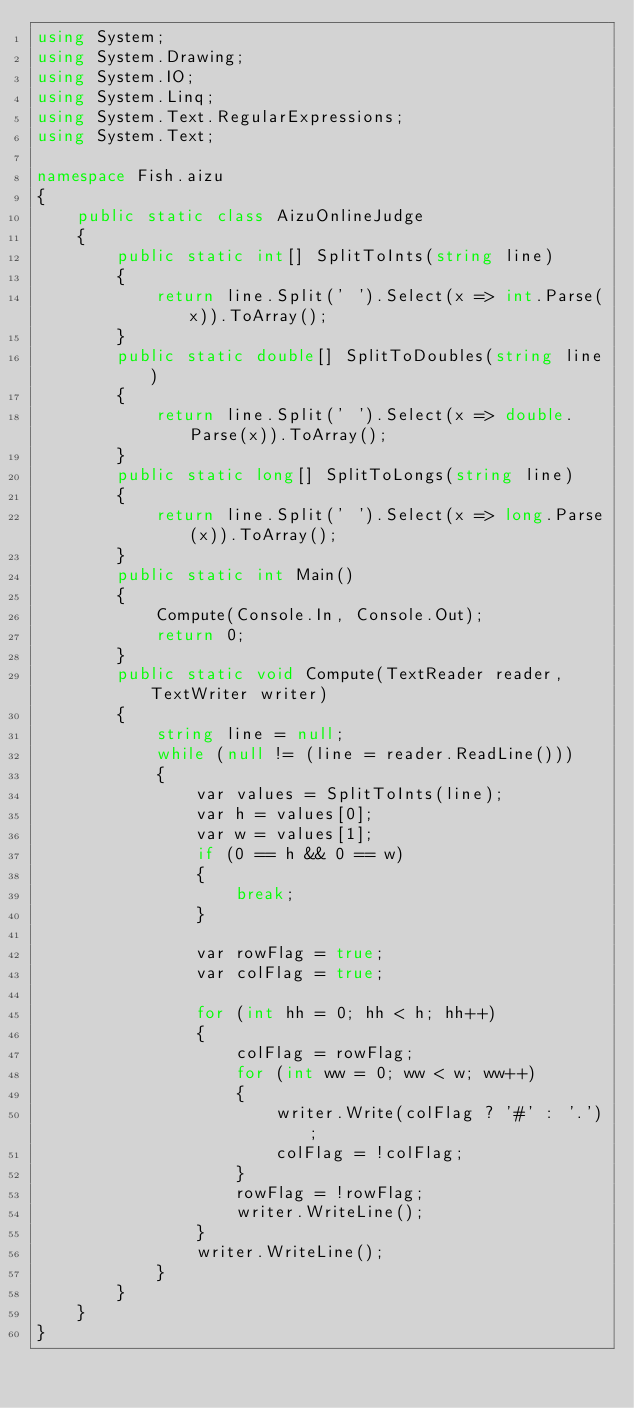Convert code to text. <code><loc_0><loc_0><loc_500><loc_500><_C#_>using System;
using System.Drawing;
using System.IO;
using System.Linq;
using System.Text.RegularExpressions;
using System.Text;

namespace Fish.aizu
{
	public static class AizuOnlineJudge
	{
		public static int[] SplitToInts(string line)
		{
			return line.Split(' ').Select(x => int.Parse(x)).ToArray();
		}
		public static double[] SplitToDoubles(string line)
		{
			return line.Split(' ').Select(x => double.Parse(x)).ToArray();
		}
		public static long[] SplitToLongs(string line)
		{
			return line.Split(' ').Select(x => long.Parse(x)).ToArray();
		}
		public static int Main()
		{
			Compute(Console.In, Console.Out);
			return 0;
		}
		public static void Compute(TextReader reader, TextWriter writer)
		{
			string line = null;
			while (null != (line = reader.ReadLine()))
			{
				var values = SplitToInts(line);
				var h = values[0];
				var w = values[1];
				if (0 == h && 0 == w)
				{
					break;
				}
				
				var rowFlag = true;
				var colFlag = true;
				
				for (int hh = 0; hh < h; hh++)
				{
					colFlag = rowFlag;
					for (int ww = 0; ww < w; ww++)
					{
						writer.Write(colFlag ? '#' : '.');
						colFlag = !colFlag;
					}
					rowFlag = !rowFlag;
					writer.WriteLine();
				}
				writer.WriteLine();
			}
		}
	}
}</code> 